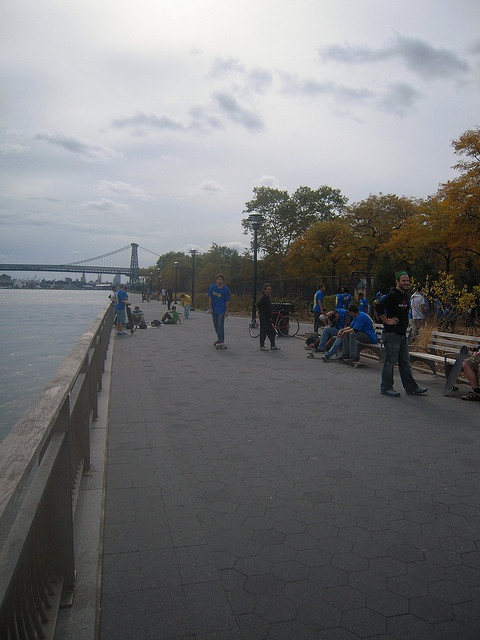Describe the objects in this image and their specific colors. I can see people in lightgray, black, gray, maroon, and navy tones, people in lightgray, black, gray, and navy tones, bench in lightgray, black, gray, and darkgray tones, people in lightgray, black, navy, and gray tones, and people in lightgray, navy, black, and gray tones in this image. 